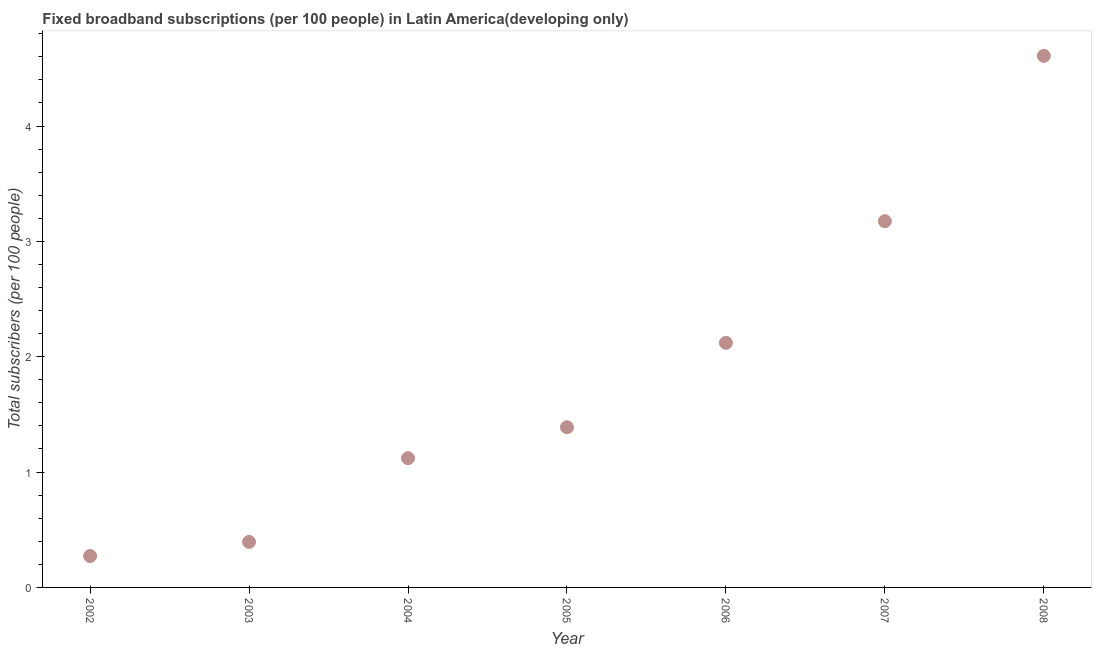What is the total number of fixed broadband subscriptions in 2003?
Make the answer very short. 0.39. Across all years, what is the maximum total number of fixed broadband subscriptions?
Ensure brevity in your answer.  4.61. Across all years, what is the minimum total number of fixed broadband subscriptions?
Ensure brevity in your answer.  0.27. In which year was the total number of fixed broadband subscriptions minimum?
Ensure brevity in your answer.  2002. What is the sum of the total number of fixed broadband subscriptions?
Your response must be concise. 13.08. What is the difference between the total number of fixed broadband subscriptions in 2002 and 2003?
Ensure brevity in your answer.  -0.12. What is the average total number of fixed broadband subscriptions per year?
Your answer should be very brief. 1.87. What is the median total number of fixed broadband subscriptions?
Offer a terse response. 1.39. In how many years, is the total number of fixed broadband subscriptions greater than 1 ?
Your response must be concise. 5. What is the ratio of the total number of fixed broadband subscriptions in 2002 to that in 2008?
Offer a terse response. 0.06. Is the total number of fixed broadband subscriptions in 2003 less than that in 2005?
Keep it short and to the point. Yes. Is the difference between the total number of fixed broadband subscriptions in 2003 and 2008 greater than the difference between any two years?
Your answer should be compact. No. What is the difference between the highest and the second highest total number of fixed broadband subscriptions?
Keep it short and to the point. 1.43. Is the sum of the total number of fixed broadband subscriptions in 2002 and 2007 greater than the maximum total number of fixed broadband subscriptions across all years?
Your answer should be very brief. No. What is the difference between the highest and the lowest total number of fixed broadband subscriptions?
Your answer should be compact. 4.34. Does the total number of fixed broadband subscriptions monotonically increase over the years?
Offer a terse response. Yes. How many dotlines are there?
Give a very brief answer. 1. What is the difference between two consecutive major ticks on the Y-axis?
Offer a terse response. 1. What is the title of the graph?
Keep it short and to the point. Fixed broadband subscriptions (per 100 people) in Latin America(developing only). What is the label or title of the X-axis?
Keep it short and to the point. Year. What is the label or title of the Y-axis?
Give a very brief answer. Total subscribers (per 100 people). What is the Total subscribers (per 100 people) in 2002?
Provide a succinct answer. 0.27. What is the Total subscribers (per 100 people) in 2003?
Give a very brief answer. 0.39. What is the Total subscribers (per 100 people) in 2004?
Offer a terse response. 1.12. What is the Total subscribers (per 100 people) in 2005?
Offer a very short reply. 1.39. What is the Total subscribers (per 100 people) in 2006?
Your response must be concise. 2.12. What is the Total subscribers (per 100 people) in 2007?
Provide a succinct answer. 3.17. What is the Total subscribers (per 100 people) in 2008?
Give a very brief answer. 4.61. What is the difference between the Total subscribers (per 100 people) in 2002 and 2003?
Offer a terse response. -0.12. What is the difference between the Total subscribers (per 100 people) in 2002 and 2004?
Make the answer very short. -0.85. What is the difference between the Total subscribers (per 100 people) in 2002 and 2005?
Keep it short and to the point. -1.12. What is the difference between the Total subscribers (per 100 people) in 2002 and 2006?
Offer a terse response. -1.85. What is the difference between the Total subscribers (per 100 people) in 2002 and 2007?
Offer a terse response. -2.9. What is the difference between the Total subscribers (per 100 people) in 2002 and 2008?
Your response must be concise. -4.34. What is the difference between the Total subscribers (per 100 people) in 2003 and 2004?
Your response must be concise. -0.73. What is the difference between the Total subscribers (per 100 people) in 2003 and 2005?
Ensure brevity in your answer.  -0.99. What is the difference between the Total subscribers (per 100 people) in 2003 and 2006?
Your answer should be very brief. -1.73. What is the difference between the Total subscribers (per 100 people) in 2003 and 2007?
Your response must be concise. -2.78. What is the difference between the Total subscribers (per 100 people) in 2003 and 2008?
Offer a very short reply. -4.21. What is the difference between the Total subscribers (per 100 people) in 2004 and 2005?
Make the answer very short. -0.27. What is the difference between the Total subscribers (per 100 people) in 2004 and 2006?
Your response must be concise. -1. What is the difference between the Total subscribers (per 100 people) in 2004 and 2007?
Offer a very short reply. -2.05. What is the difference between the Total subscribers (per 100 people) in 2004 and 2008?
Your answer should be compact. -3.49. What is the difference between the Total subscribers (per 100 people) in 2005 and 2006?
Give a very brief answer. -0.73. What is the difference between the Total subscribers (per 100 people) in 2005 and 2007?
Your answer should be very brief. -1.79. What is the difference between the Total subscribers (per 100 people) in 2005 and 2008?
Give a very brief answer. -3.22. What is the difference between the Total subscribers (per 100 people) in 2006 and 2007?
Provide a succinct answer. -1.05. What is the difference between the Total subscribers (per 100 people) in 2006 and 2008?
Give a very brief answer. -2.49. What is the difference between the Total subscribers (per 100 people) in 2007 and 2008?
Provide a succinct answer. -1.43. What is the ratio of the Total subscribers (per 100 people) in 2002 to that in 2003?
Offer a terse response. 0.69. What is the ratio of the Total subscribers (per 100 people) in 2002 to that in 2004?
Offer a very short reply. 0.24. What is the ratio of the Total subscribers (per 100 people) in 2002 to that in 2005?
Provide a short and direct response. 0.2. What is the ratio of the Total subscribers (per 100 people) in 2002 to that in 2006?
Provide a succinct answer. 0.13. What is the ratio of the Total subscribers (per 100 people) in 2002 to that in 2007?
Offer a terse response. 0.09. What is the ratio of the Total subscribers (per 100 people) in 2002 to that in 2008?
Your answer should be very brief. 0.06. What is the ratio of the Total subscribers (per 100 people) in 2003 to that in 2004?
Keep it short and to the point. 0.35. What is the ratio of the Total subscribers (per 100 people) in 2003 to that in 2005?
Make the answer very short. 0.28. What is the ratio of the Total subscribers (per 100 people) in 2003 to that in 2006?
Your answer should be compact. 0.19. What is the ratio of the Total subscribers (per 100 people) in 2003 to that in 2007?
Offer a very short reply. 0.12. What is the ratio of the Total subscribers (per 100 people) in 2003 to that in 2008?
Make the answer very short. 0.09. What is the ratio of the Total subscribers (per 100 people) in 2004 to that in 2005?
Make the answer very short. 0.81. What is the ratio of the Total subscribers (per 100 people) in 2004 to that in 2006?
Provide a short and direct response. 0.53. What is the ratio of the Total subscribers (per 100 people) in 2004 to that in 2007?
Ensure brevity in your answer.  0.35. What is the ratio of the Total subscribers (per 100 people) in 2004 to that in 2008?
Keep it short and to the point. 0.24. What is the ratio of the Total subscribers (per 100 people) in 2005 to that in 2006?
Offer a very short reply. 0.66. What is the ratio of the Total subscribers (per 100 people) in 2005 to that in 2007?
Your response must be concise. 0.44. What is the ratio of the Total subscribers (per 100 people) in 2005 to that in 2008?
Your answer should be very brief. 0.3. What is the ratio of the Total subscribers (per 100 people) in 2006 to that in 2007?
Offer a terse response. 0.67. What is the ratio of the Total subscribers (per 100 people) in 2006 to that in 2008?
Your answer should be very brief. 0.46. What is the ratio of the Total subscribers (per 100 people) in 2007 to that in 2008?
Your response must be concise. 0.69. 